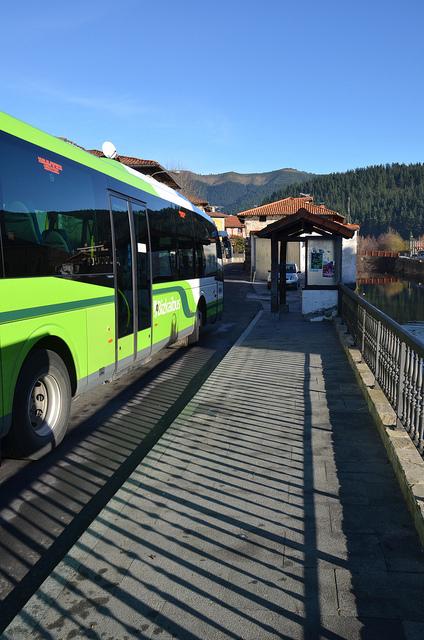Is the sky cloudy?
Concise answer only. No. What color is the bus?
Be succinct. Green. Is the bus driving toward us?
Keep it brief. No. 